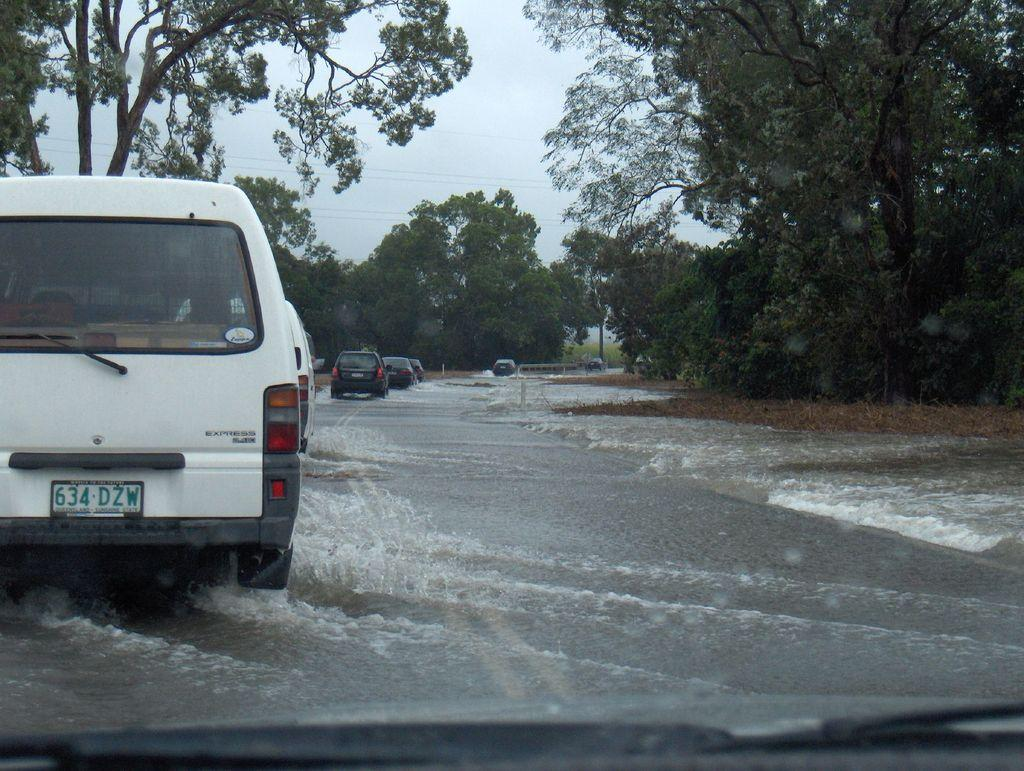What is on the road in the image? There is water on the road in the image. What type of vehicles can be seen in the image? There are cars in the image. What type of vegetation is present in the image? There are trees in the image. What is visible in the background of the image? The sky is visible in the image. What is the condition of the sky in the image? The sky is cloudy in the image. How many shoes are hanging from the trees in the image? There are no shoes hanging from the trees in the image; only cars, water, trees, and a cloudy sky are present. What type of root can be seen growing from the water on the road? There is no root visible in the image; it features water on the road, cars, trees, and a cloudy sky. 